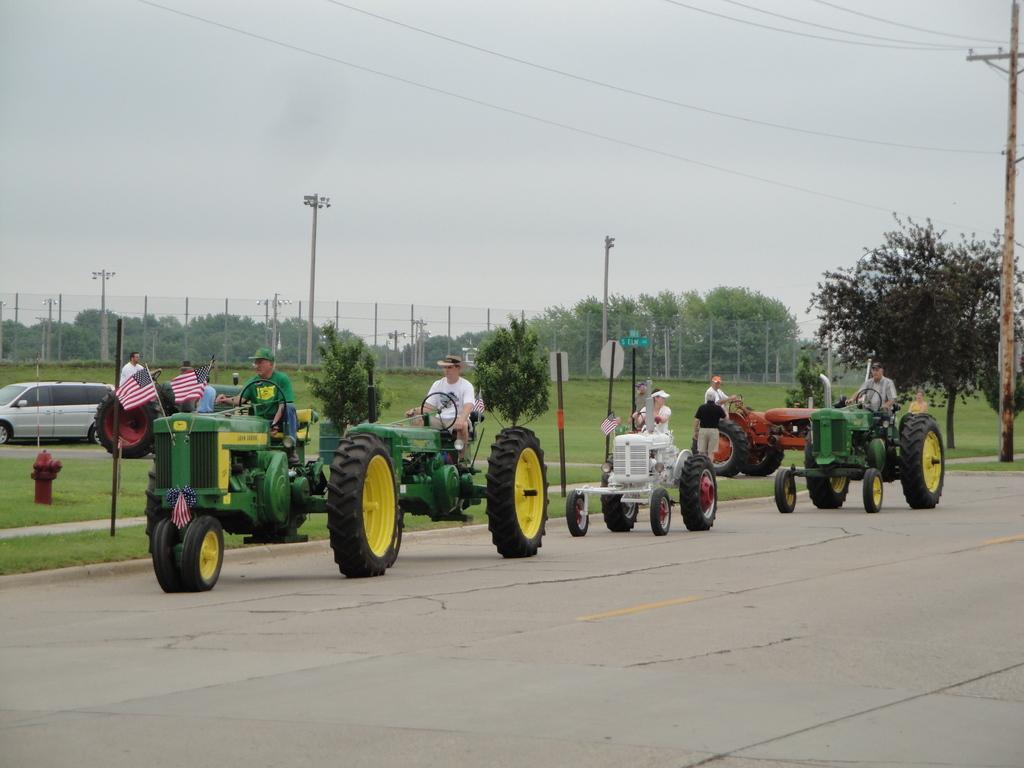Please provide a concise description of this image. In the center of the image we can see some people are driving the tractors. In the background of the image we can see the trees, poles, lights, boards, grass, fence, flags, car. At the bottom of the image we can see the road. At the top of the image we can see the wires and sky. 